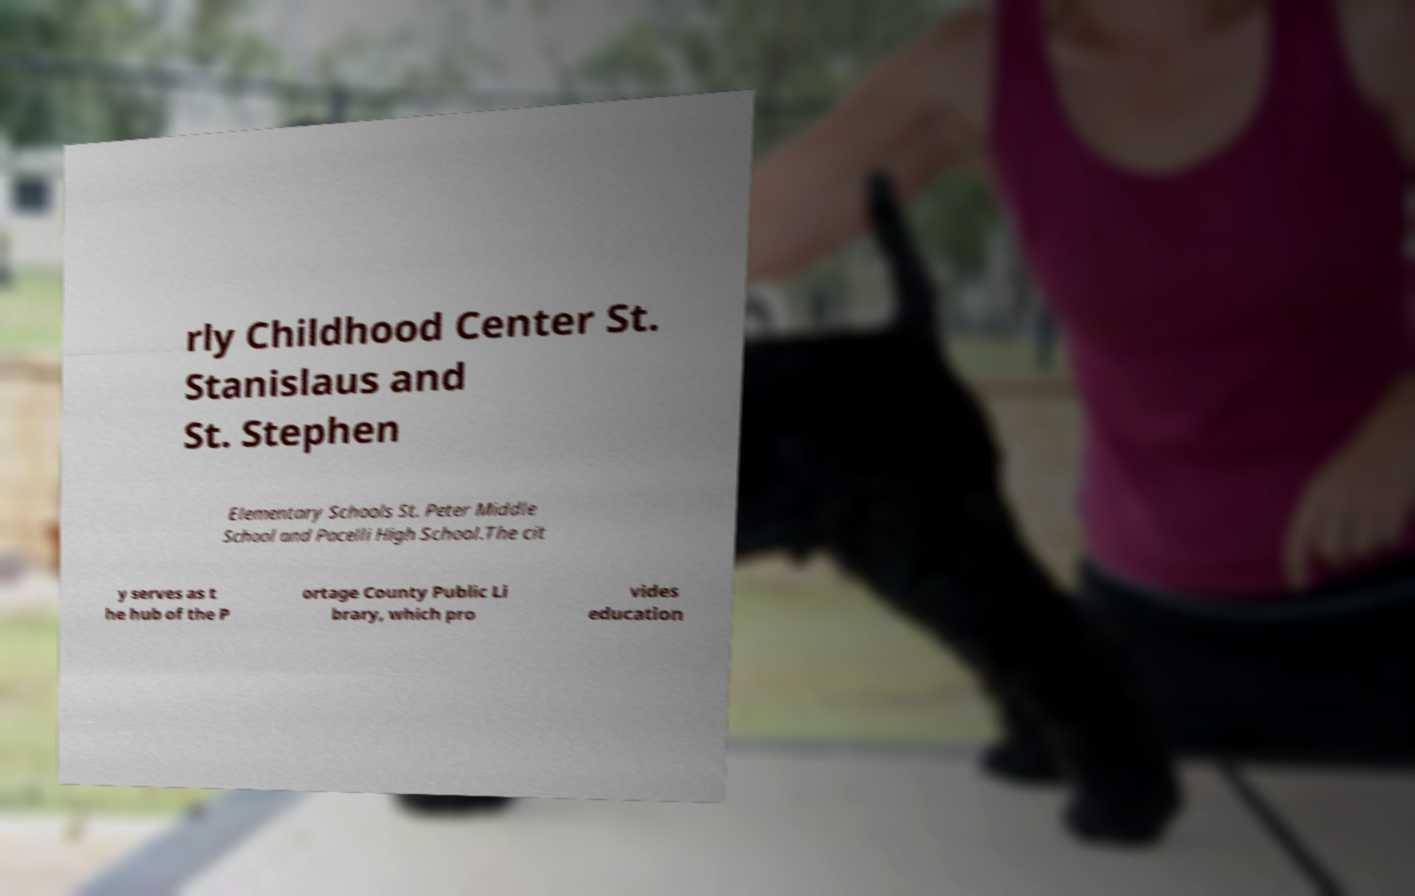There's text embedded in this image that I need extracted. Can you transcribe it verbatim? rly Childhood Center St. Stanislaus and St. Stephen Elementary Schools St. Peter Middle School and Pacelli High School.The cit y serves as t he hub of the P ortage County Public Li brary, which pro vides education 